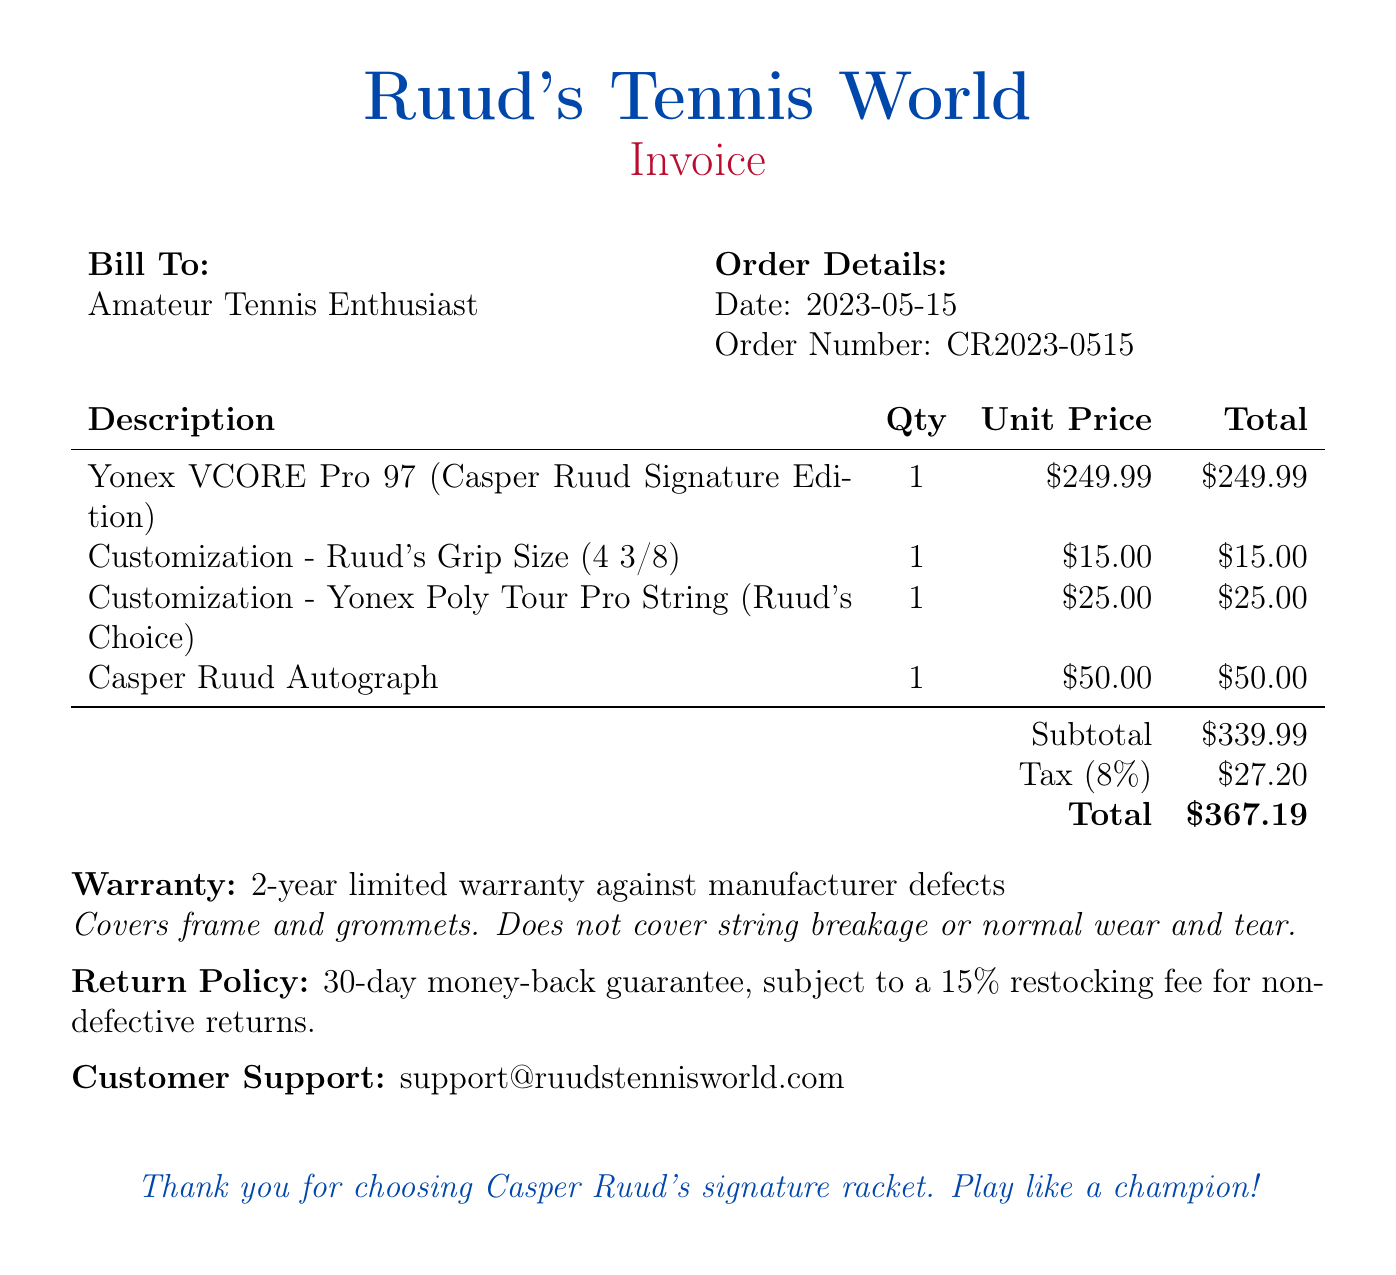what is the order number? The order number is provided in the "Order Details" section: CR2023-0515.
Answer: CR2023-0515 what is the unit price of the racket? The unit price for the racket is listed in the itemized description: $249.99.
Answer: $249.99 how much is the customization for the grip size? The customization charge for Ruud's grip size is specified in the bill: $15.00.
Answer: $15.00 what is the tax percentage applied to the bill? The tax percentage is mentioned in the subtotal area of the bill: 8%.
Answer: 8% how long is the warranty for the racket? The warranty period is stated in the warranty section: 2-year limited warranty.
Answer: 2-year what does the warranty cover? The warranty details mention coverage for manufacturer defects: frame and grommets.
Answer: frame and grommets how much is the total amount payable? The total amount is the sum of the subtotal and tax, as stated at the end of the itemized list: $367.19.
Answer: $367.19 are returns allowed after purchase? The return policy mentions a money-back guarantee: 30-day money-back guarantee.
Answer: 30-day money-back guarantee what is the restocking fee for non-defective returns? The restocking fee is specified in the return policy section: 15%.
Answer: 15% 